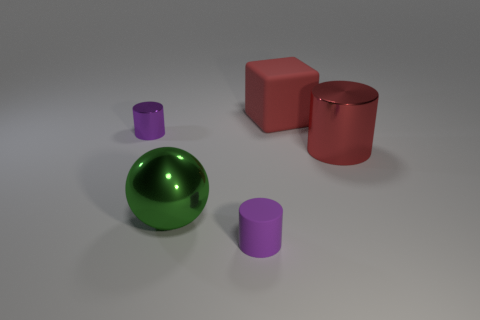Subtract all red balls. Subtract all brown blocks. How many balls are left? 1 Add 5 large red cylinders. How many objects exist? 10 Subtract all cubes. How many objects are left? 4 Subtract all gray metallic blocks. Subtract all tiny purple shiny objects. How many objects are left? 4 Add 5 green shiny spheres. How many green shiny spheres are left? 6 Add 3 red matte things. How many red matte things exist? 4 Subtract 1 red blocks. How many objects are left? 4 